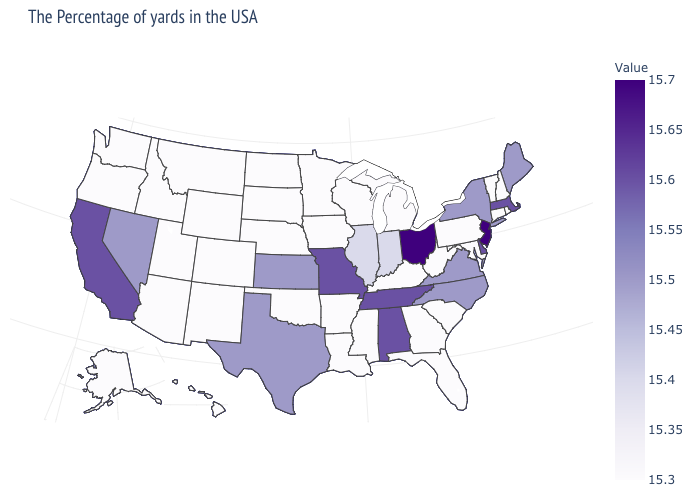Does Virginia have a higher value than South Dakota?
Keep it brief. Yes. Does North Dakota have the lowest value in the MidWest?
Quick response, please. Yes. Does Mississippi have the lowest value in the USA?
Be succinct. Yes. Does California have the highest value in the USA?
Keep it brief. No. Which states hav the highest value in the South?
Be succinct. Delaware, Alabama, Tennessee. Does Oregon have the lowest value in the USA?
Be succinct. Yes. Does Montana have the lowest value in the West?
Concise answer only. Yes. Among the states that border Louisiana , which have the highest value?
Keep it brief. Texas. 